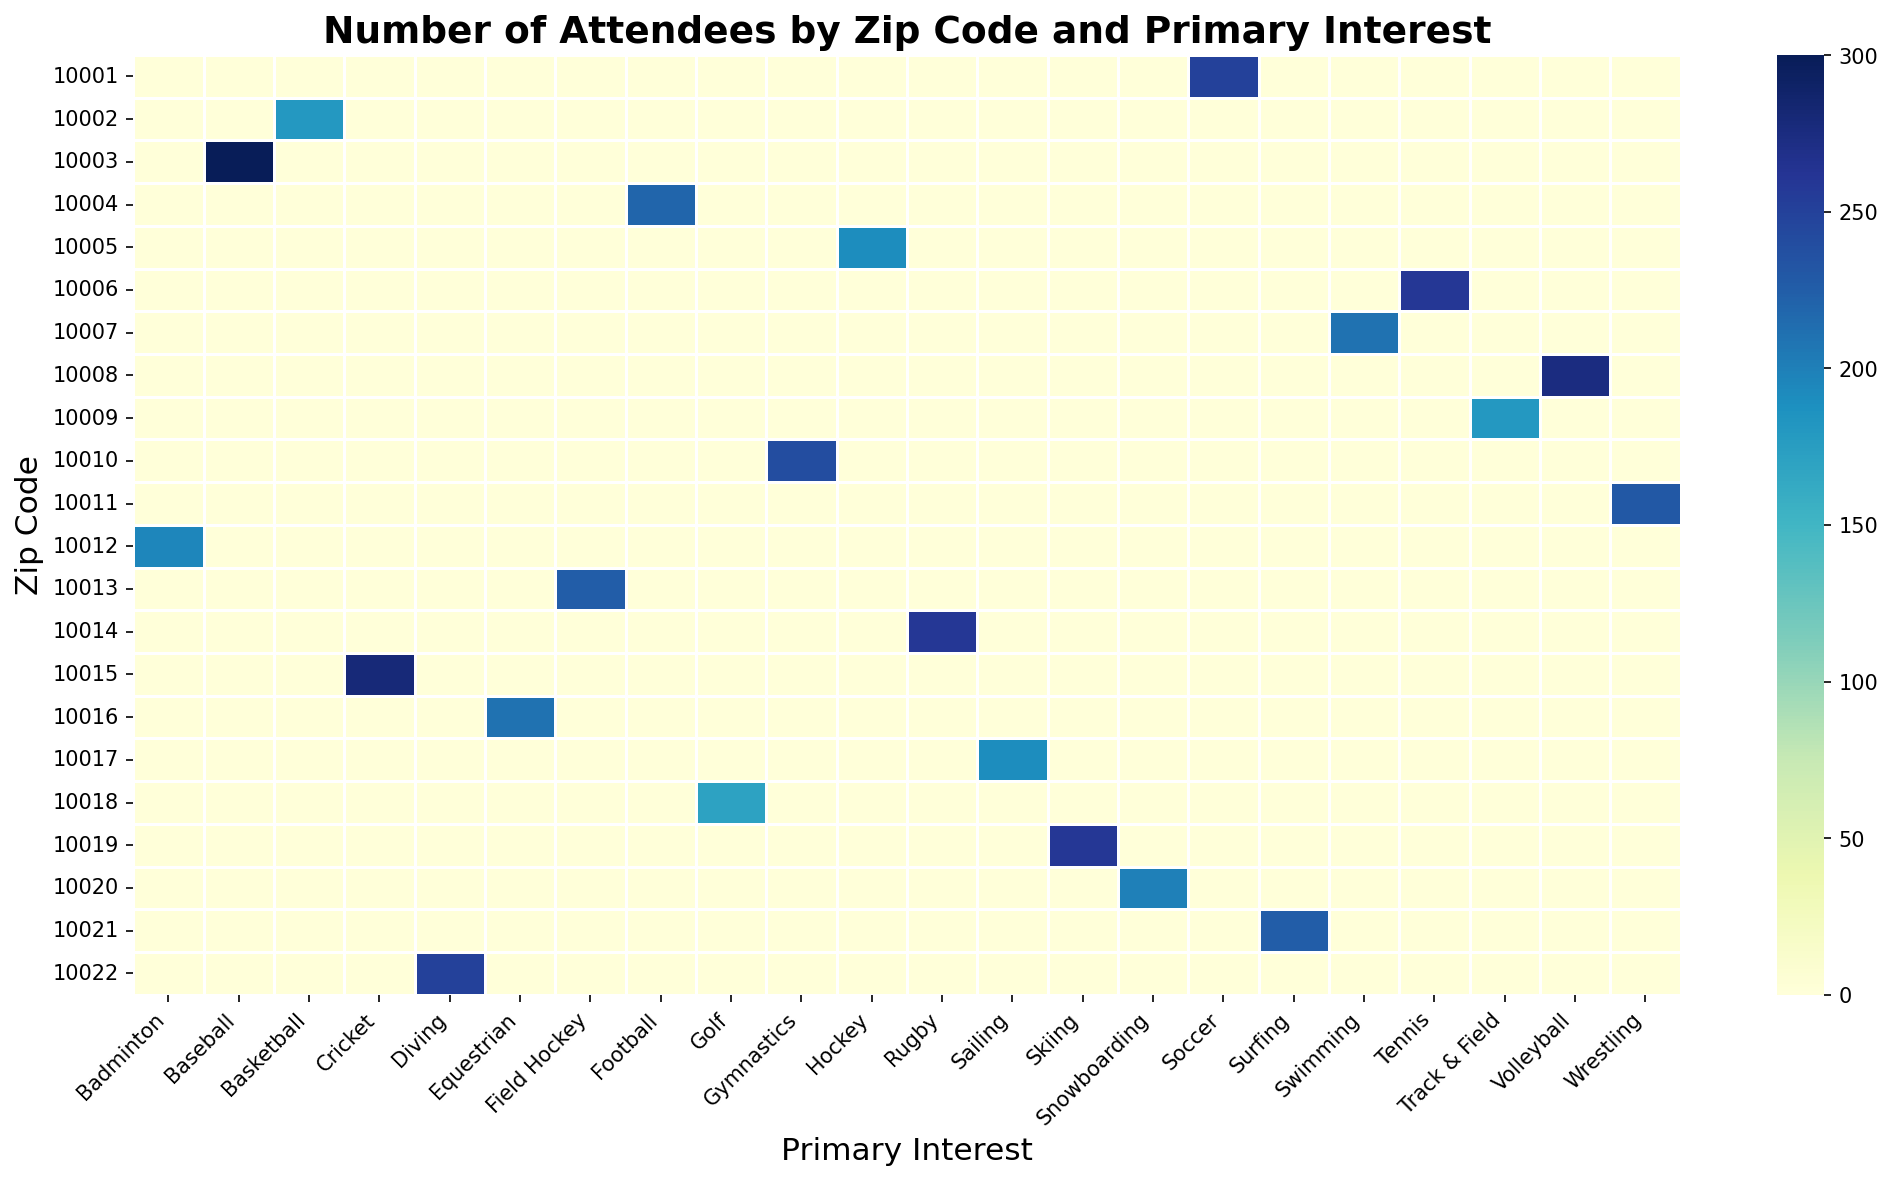What zip code has the highest number of attendees for soccer events? To find this, look for the cell under "Soccer" with the highest value and check its corresponding row label, which represents the zip code.
Answer: 10001 Which sport has the lowest number of attendees in zip code 10003? Identify the row labeled "10003" and find the column with the smallest number. The column label represents the primary interest with the lowest number of attendees in that zip code.
Answer: Field Hockey Between Hockey and Tennis, which sport has a higher number of attendees in zip code 10005? Locate the row labeled "10005" and compare the values under "Hockey" and "Tennis". The higher value indicates the sport with more attendees.
Answer: Hockey What is the sum of attendees from zip codes 10008 and 10014 for Volleyball? Identify the values under the "Volleyball" column for zip codes "10008" and "10014", then add them together: 275 + 0 (since 10014 doesn't have volleyball) = 275.
Answer: 275 Is the number of attendees for Sailing in zip code 10017 more than for Baseball in zip code 10003? Locate the values for "Sailing" in row "10017" and for "Baseball" in row "10003". Compare these values directly.
Answer: Yes What is the average number of attendees for Basketball in the zip codes 10002, 10013, and 10020? Get the values under the "Basketball" column for the zip codes "10002", "10013" and "10020". Calculate the average: sum (180 + 0 + 0) = 180, then divide by 3 which gives 180/3 = 60.
Answer: 60 How does the number of attendees for Rugby in zip code 10014 compare visually to Swimming in zip code 10007? Check the cells where rows "10014" and "10007" intersect with columns "Rugby" and "Swimming". Compare the color intensity or height visually to see which is higher.
Answer: Rugby has more attendees By how much does the number of attendees for Cricket in zip code 10015 exceed the number of attendees for Golf in zip code 10018? Locate the values for "Cricket" and "Golf" in rows "10015" and "10018" respectively. Subtract the smaller value (Golf) from the larger value (Cricket): 280 - 170 = 110.
Answer: 110 What is the total number of attendees in zip code 10001 across all events? Add all the values in the row labeled "10001": 250. This is because the plot only shows individual sports' attendees without summing across different interest columns.
Answer: 250 